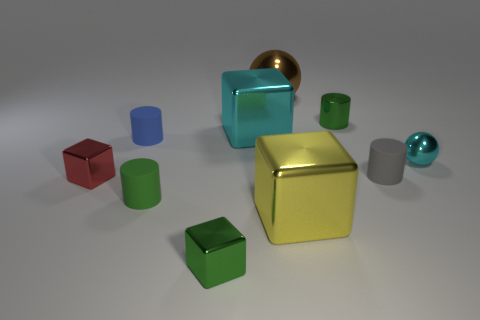Subtract all balls. How many objects are left? 8 Add 9 red blocks. How many red blocks are left? 10 Add 1 big red metallic cubes. How many big red metallic cubes exist? 1 Subtract 0 brown cylinders. How many objects are left? 10 Subtract all brown things. Subtract all tiny red objects. How many objects are left? 8 